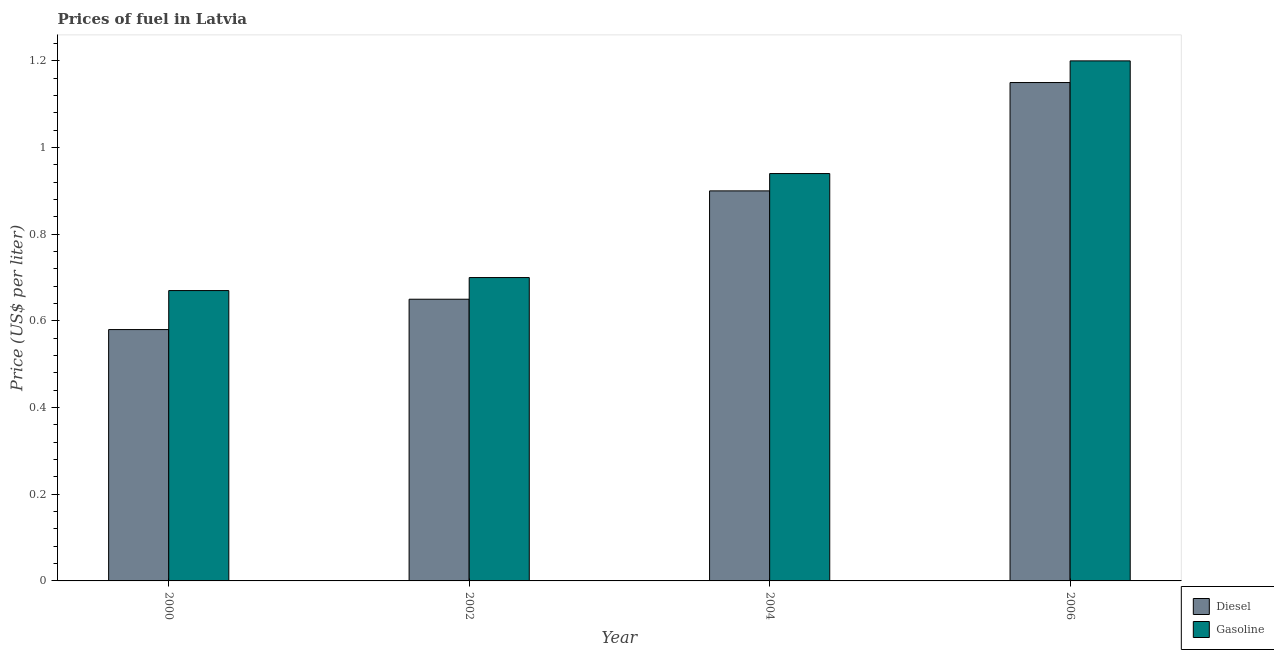How many different coloured bars are there?
Provide a succinct answer. 2. How many groups of bars are there?
Make the answer very short. 4. Are the number of bars on each tick of the X-axis equal?
Provide a short and direct response. Yes. What is the diesel price in 2002?
Provide a short and direct response. 0.65. Across all years, what is the minimum gasoline price?
Provide a succinct answer. 0.67. In which year was the gasoline price minimum?
Offer a terse response. 2000. What is the total gasoline price in the graph?
Make the answer very short. 3.51. What is the difference between the gasoline price in 2000 and that in 2004?
Ensure brevity in your answer.  -0.27. What is the difference between the gasoline price in 2000 and the diesel price in 2002?
Offer a very short reply. -0.03. What is the average diesel price per year?
Your answer should be compact. 0.82. In the year 2006, what is the difference between the gasoline price and diesel price?
Provide a succinct answer. 0. What is the ratio of the diesel price in 2002 to that in 2006?
Provide a short and direct response. 0.57. What is the difference between the highest and the second highest gasoline price?
Your response must be concise. 0.26. What is the difference between the highest and the lowest diesel price?
Ensure brevity in your answer.  0.57. Is the sum of the diesel price in 2002 and 2006 greater than the maximum gasoline price across all years?
Offer a very short reply. Yes. What does the 2nd bar from the left in 2002 represents?
Make the answer very short. Gasoline. What does the 2nd bar from the right in 2006 represents?
Keep it short and to the point. Diesel. How many bars are there?
Your answer should be very brief. 8. Does the graph contain grids?
Give a very brief answer. No. Where does the legend appear in the graph?
Ensure brevity in your answer.  Bottom right. How are the legend labels stacked?
Your answer should be compact. Vertical. What is the title of the graph?
Offer a terse response. Prices of fuel in Latvia. Does "GDP at market prices" appear as one of the legend labels in the graph?
Give a very brief answer. No. What is the label or title of the Y-axis?
Your answer should be compact. Price (US$ per liter). What is the Price (US$ per liter) of Diesel in 2000?
Provide a succinct answer. 0.58. What is the Price (US$ per liter) in Gasoline in 2000?
Provide a succinct answer. 0.67. What is the Price (US$ per liter) in Diesel in 2002?
Ensure brevity in your answer.  0.65. What is the Price (US$ per liter) in Diesel in 2006?
Give a very brief answer. 1.15. Across all years, what is the maximum Price (US$ per liter) of Diesel?
Your response must be concise. 1.15. Across all years, what is the maximum Price (US$ per liter) in Gasoline?
Ensure brevity in your answer.  1.2. Across all years, what is the minimum Price (US$ per liter) in Diesel?
Provide a short and direct response. 0.58. Across all years, what is the minimum Price (US$ per liter) in Gasoline?
Provide a succinct answer. 0.67. What is the total Price (US$ per liter) in Diesel in the graph?
Your response must be concise. 3.28. What is the total Price (US$ per liter) in Gasoline in the graph?
Offer a very short reply. 3.51. What is the difference between the Price (US$ per liter) in Diesel in 2000 and that in 2002?
Make the answer very short. -0.07. What is the difference between the Price (US$ per liter) of Gasoline in 2000 and that in 2002?
Your response must be concise. -0.03. What is the difference between the Price (US$ per liter) in Diesel in 2000 and that in 2004?
Ensure brevity in your answer.  -0.32. What is the difference between the Price (US$ per liter) in Gasoline in 2000 and that in 2004?
Your response must be concise. -0.27. What is the difference between the Price (US$ per liter) of Diesel in 2000 and that in 2006?
Give a very brief answer. -0.57. What is the difference between the Price (US$ per liter) in Gasoline in 2000 and that in 2006?
Provide a succinct answer. -0.53. What is the difference between the Price (US$ per liter) in Gasoline in 2002 and that in 2004?
Provide a short and direct response. -0.24. What is the difference between the Price (US$ per liter) of Diesel in 2004 and that in 2006?
Keep it short and to the point. -0.25. What is the difference between the Price (US$ per liter) of Gasoline in 2004 and that in 2006?
Ensure brevity in your answer.  -0.26. What is the difference between the Price (US$ per liter) in Diesel in 2000 and the Price (US$ per liter) in Gasoline in 2002?
Your answer should be compact. -0.12. What is the difference between the Price (US$ per liter) of Diesel in 2000 and the Price (US$ per liter) of Gasoline in 2004?
Your answer should be very brief. -0.36. What is the difference between the Price (US$ per liter) in Diesel in 2000 and the Price (US$ per liter) in Gasoline in 2006?
Give a very brief answer. -0.62. What is the difference between the Price (US$ per liter) in Diesel in 2002 and the Price (US$ per liter) in Gasoline in 2004?
Ensure brevity in your answer.  -0.29. What is the difference between the Price (US$ per liter) in Diesel in 2002 and the Price (US$ per liter) in Gasoline in 2006?
Give a very brief answer. -0.55. What is the average Price (US$ per liter) of Diesel per year?
Offer a very short reply. 0.82. What is the average Price (US$ per liter) in Gasoline per year?
Your answer should be compact. 0.88. In the year 2000, what is the difference between the Price (US$ per liter) in Diesel and Price (US$ per liter) in Gasoline?
Keep it short and to the point. -0.09. In the year 2002, what is the difference between the Price (US$ per liter) of Diesel and Price (US$ per liter) of Gasoline?
Make the answer very short. -0.05. In the year 2004, what is the difference between the Price (US$ per liter) in Diesel and Price (US$ per liter) in Gasoline?
Your response must be concise. -0.04. What is the ratio of the Price (US$ per liter) of Diesel in 2000 to that in 2002?
Provide a succinct answer. 0.89. What is the ratio of the Price (US$ per liter) of Gasoline in 2000 to that in 2002?
Your answer should be very brief. 0.96. What is the ratio of the Price (US$ per liter) of Diesel in 2000 to that in 2004?
Provide a succinct answer. 0.64. What is the ratio of the Price (US$ per liter) in Gasoline in 2000 to that in 2004?
Provide a short and direct response. 0.71. What is the ratio of the Price (US$ per liter) of Diesel in 2000 to that in 2006?
Your answer should be very brief. 0.5. What is the ratio of the Price (US$ per liter) in Gasoline in 2000 to that in 2006?
Provide a succinct answer. 0.56. What is the ratio of the Price (US$ per liter) in Diesel in 2002 to that in 2004?
Offer a terse response. 0.72. What is the ratio of the Price (US$ per liter) of Gasoline in 2002 to that in 2004?
Keep it short and to the point. 0.74. What is the ratio of the Price (US$ per liter) in Diesel in 2002 to that in 2006?
Offer a very short reply. 0.57. What is the ratio of the Price (US$ per liter) of Gasoline in 2002 to that in 2006?
Offer a terse response. 0.58. What is the ratio of the Price (US$ per liter) of Diesel in 2004 to that in 2006?
Offer a very short reply. 0.78. What is the ratio of the Price (US$ per liter) in Gasoline in 2004 to that in 2006?
Your answer should be compact. 0.78. What is the difference between the highest and the second highest Price (US$ per liter) in Diesel?
Your response must be concise. 0.25. What is the difference between the highest and the second highest Price (US$ per liter) of Gasoline?
Offer a terse response. 0.26. What is the difference between the highest and the lowest Price (US$ per liter) of Diesel?
Keep it short and to the point. 0.57. What is the difference between the highest and the lowest Price (US$ per liter) of Gasoline?
Make the answer very short. 0.53. 